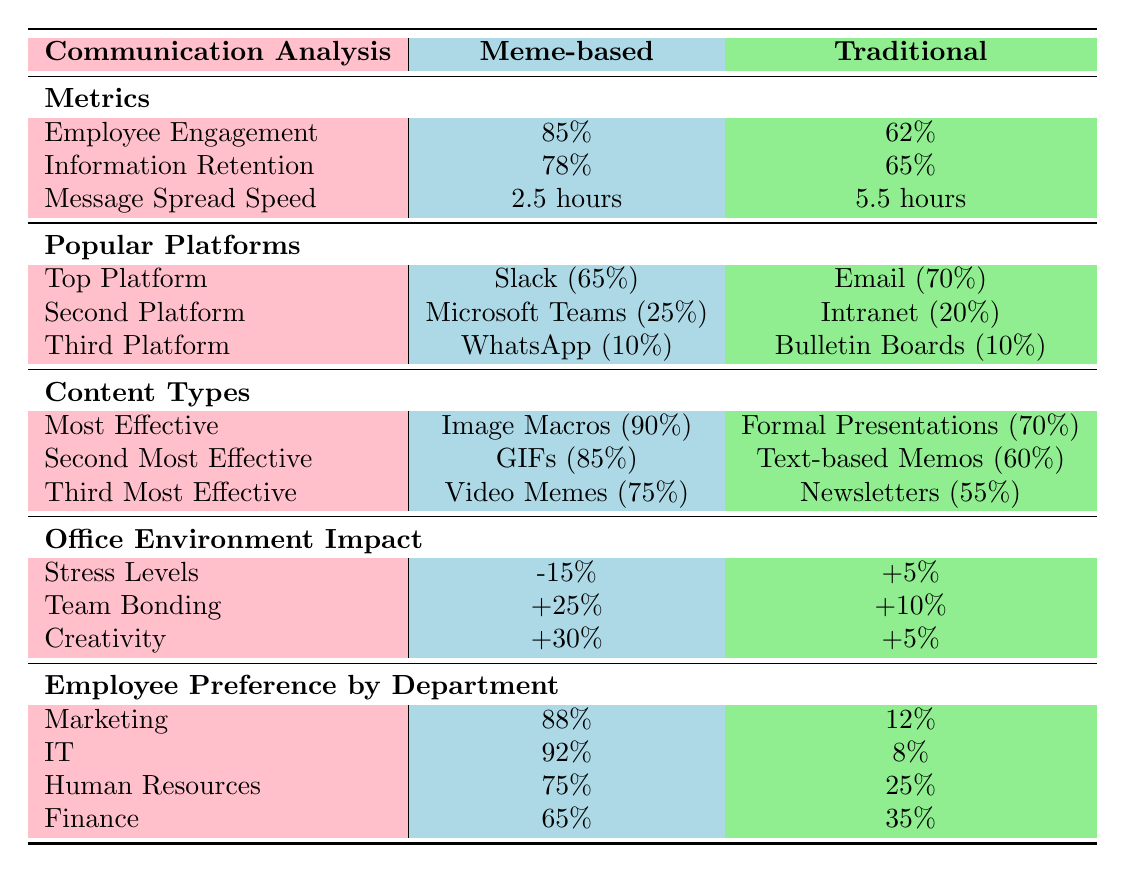What is the employee engagement percentage for meme-based communication? The table indicates that the employee engagement for meme-based communication is 85%.
Answer: 85% Which method has a faster message spread speed? According to the table, meme-based communication has a message spread speed of 2.5 hours, while traditional methods have a speed of 5.5 hours. Therefore, meme-based communication is faster.
Answer: Meme-based What is the difference in information retention between the two methods? The table shows that information retention is 78% for meme-based and 65% for traditional methods. The difference is calculated as 78% - 65% = 13%.
Answer: 13% Which popular platform is most used in the traditional communication method? The data shows that the most used platform in traditional communication is Email, with a usage percentage of 70%.
Answer: Email How effective are GIFs compared to text-based memos? GIFs are 85% effective as per the table, while text-based memos have an effectiveness of 60%. The difference in effectiveness is 85% - 60% = 25%.
Answer: 25% In which department do the majority prefer meme-based communication? The table indicates that the IT department has the highest preference for meme-based communication at 92%.
Answer: IT Is creativity higher in your office with meme-based communication? The table indicates that creativity increases by 30% with meme-based communication, while it only increases by 5% with traditional methods. Thus, the answer is yes.
Answer: Yes What is the average meme preference across all departments? To find the average meme preference, add the percentage preferences: 88 + 92 + 75 + 65 = 320, then divide by 4 (the number of departments): 320 / 4 = 80%.
Answer: 80% Which method has a greater impact on team bonding, and by how much? The impact on team bonding is 25% for meme-based communication and 10% for traditional methods. The difference is 25% - 10% = 15%. Therefore, meme-based communication has a greater impact.
Answer: Meme-based, 15% Are information retention rates higher for meme-based than traditional methods? Yes, the data shows that meme-based communication has an information retention rate of 78%, while traditional methods have a rate of 65%. Thus, meme-based communication rates are higher.
Answer: Yes 